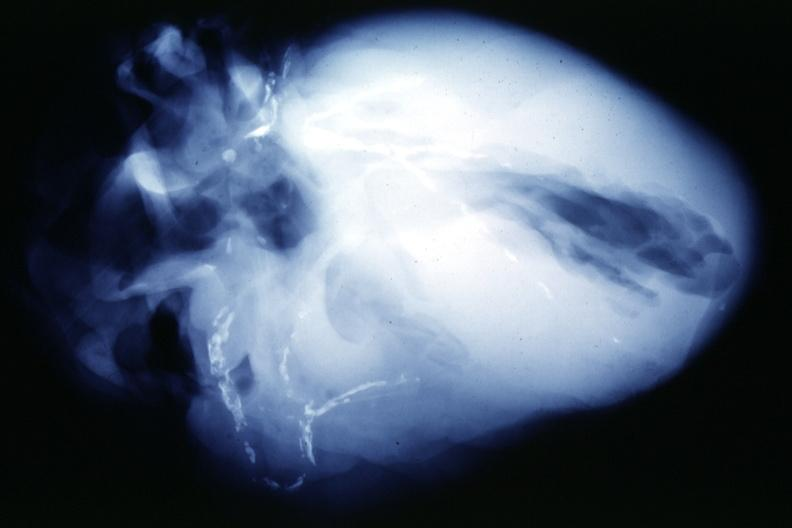s cardiovascular present?
Answer the question using a single word or phrase. Yes 